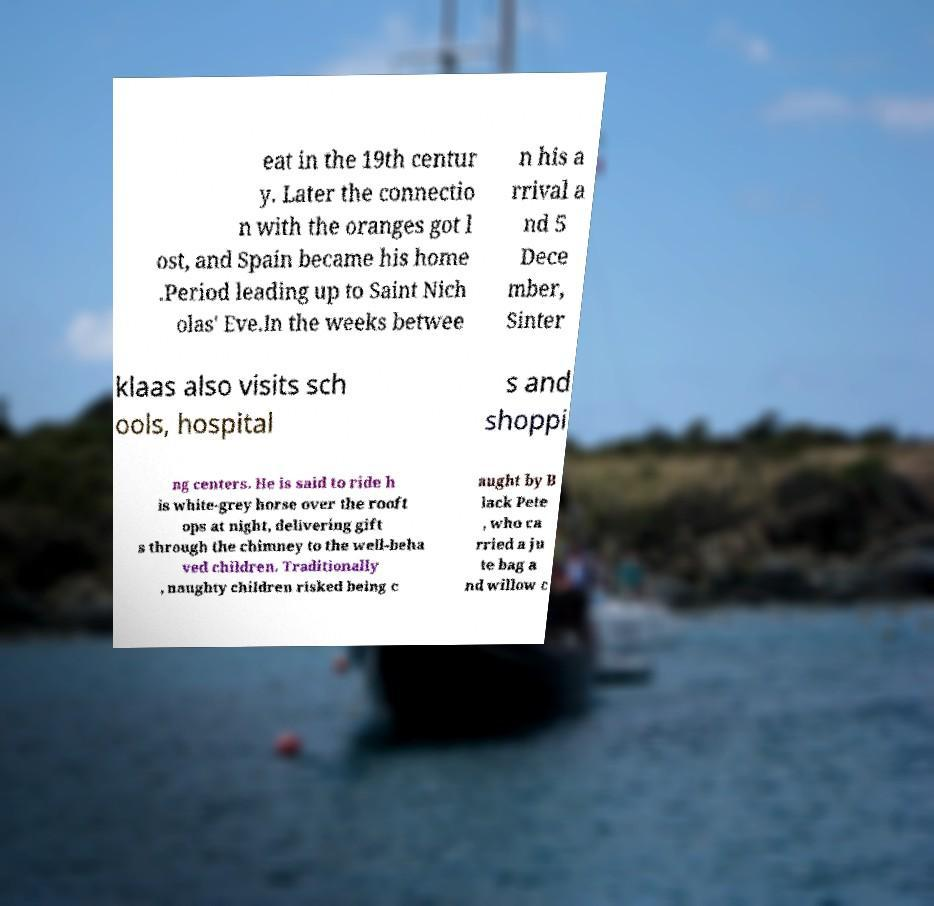Please read and relay the text visible in this image. What does it say? eat in the 19th centur y. Later the connectio n with the oranges got l ost, and Spain became his home .Period leading up to Saint Nich olas' Eve.In the weeks betwee n his a rrival a nd 5 Dece mber, Sinter klaas also visits sch ools, hospital s and shoppi ng centers. He is said to ride h is white-grey horse over the rooft ops at night, delivering gift s through the chimney to the well-beha ved children. Traditionally , naughty children risked being c aught by B lack Pete , who ca rried a ju te bag a nd willow c 